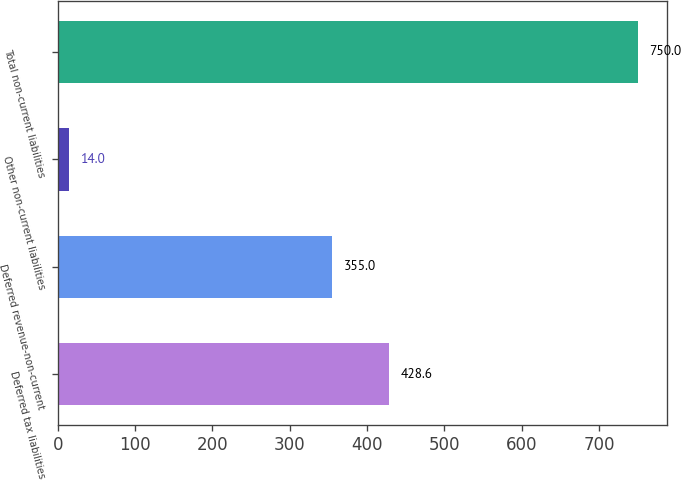Convert chart. <chart><loc_0><loc_0><loc_500><loc_500><bar_chart><fcel>Deferred tax liabilities<fcel>Deferred revenue-non-current<fcel>Other non-current liabilities<fcel>Total non-current liabilities<nl><fcel>428.6<fcel>355<fcel>14<fcel>750<nl></chart> 